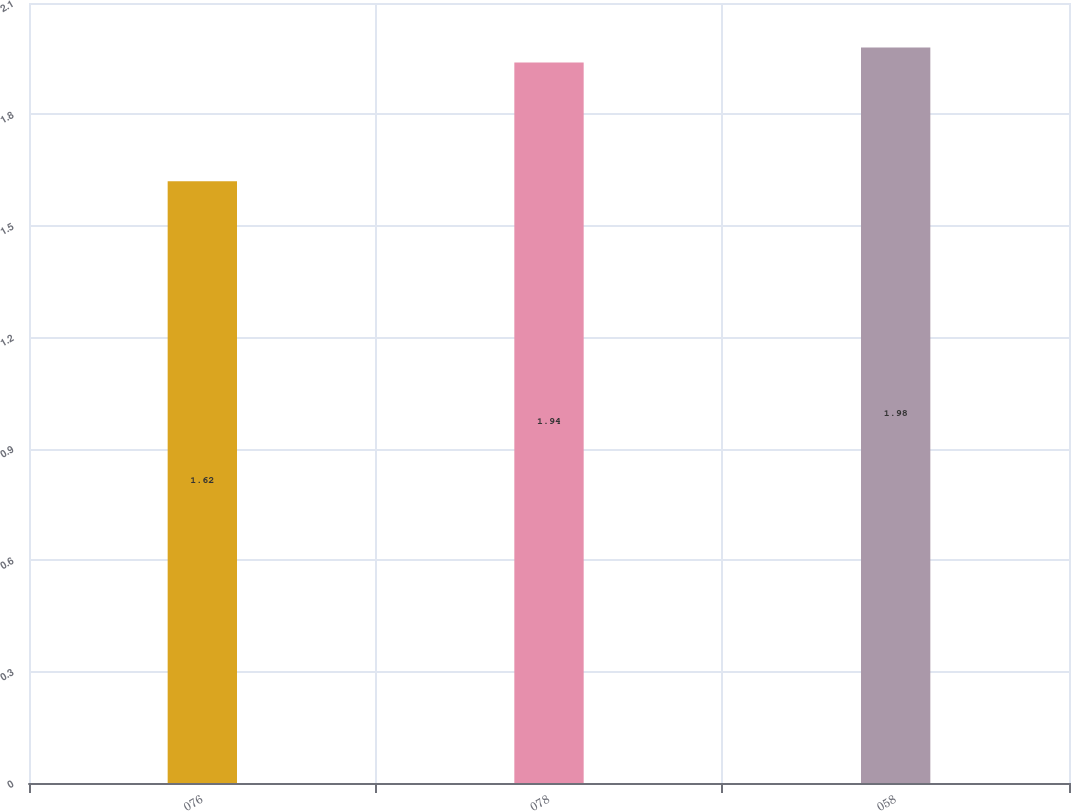Convert chart to OTSL. <chart><loc_0><loc_0><loc_500><loc_500><bar_chart><fcel>076<fcel>078<fcel>058<nl><fcel>1.62<fcel>1.94<fcel>1.98<nl></chart> 